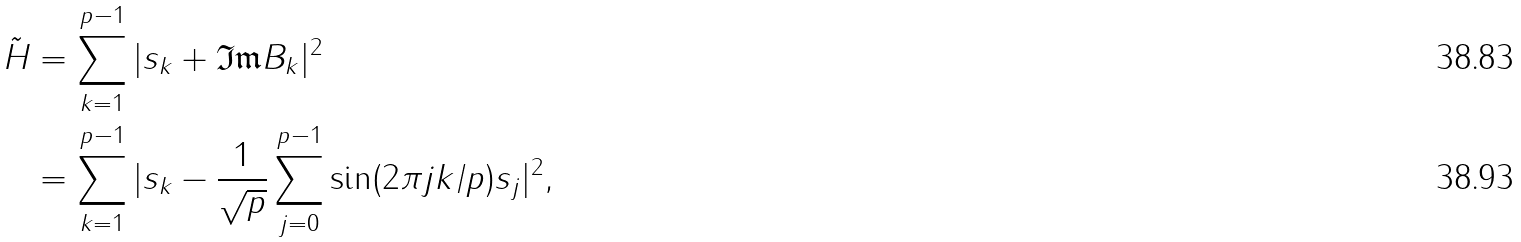<formula> <loc_0><loc_0><loc_500><loc_500>\tilde { H } & = \sum _ { k = 1 } ^ { p - 1 } | s _ { k } + \mathfrak { I m } B _ { k } | ^ { 2 } \\ & = \sum _ { k = 1 } ^ { p - 1 } | s _ { k } - \frac { 1 } { \sqrt { p } } \sum _ { j = 0 } ^ { p - 1 } \sin ( 2 \pi j k / p ) s _ { j } | ^ { 2 } ,</formula> 